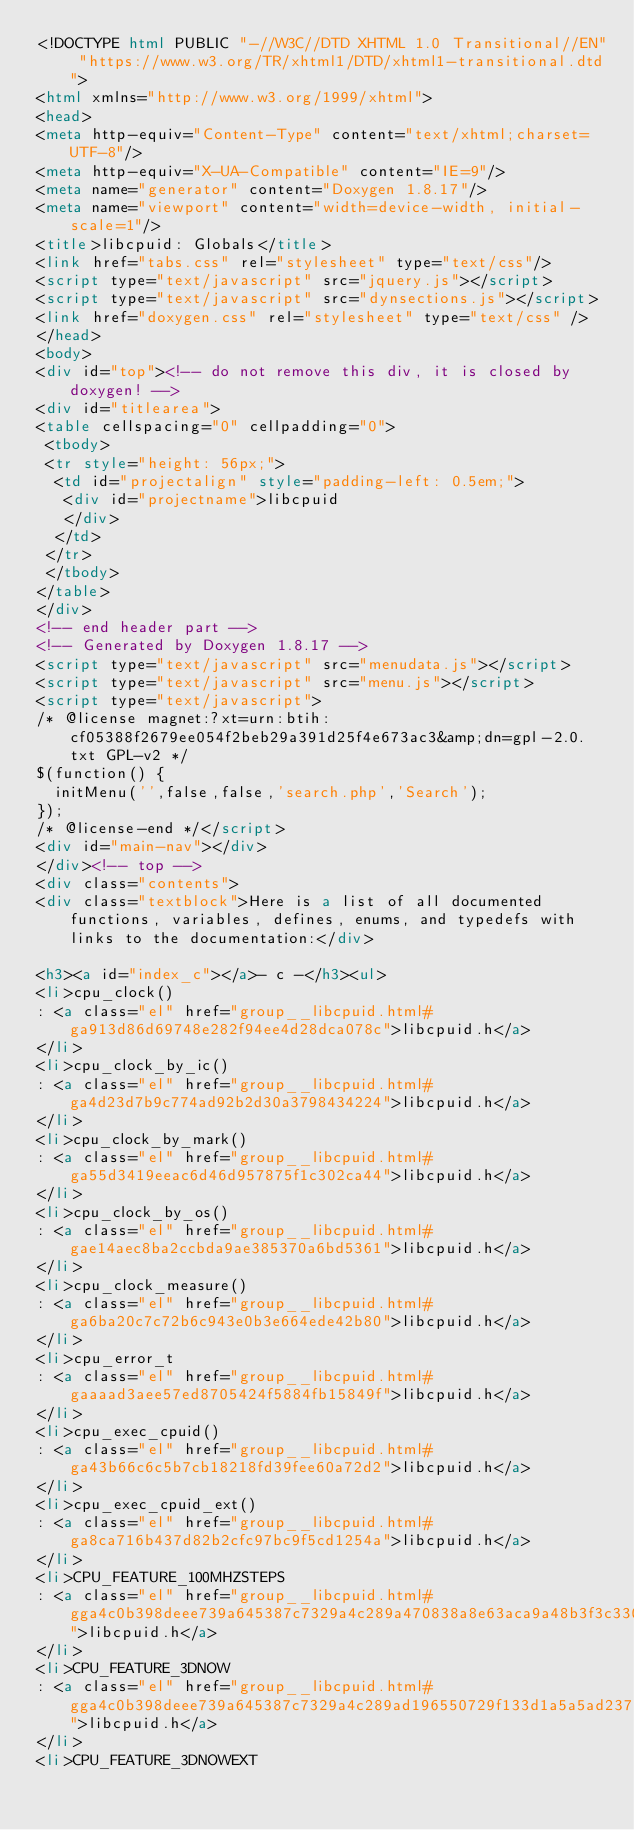Convert code to text. <code><loc_0><loc_0><loc_500><loc_500><_HTML_><!DOCTYPE html PUBLIC "-//W3C//DTD XHTML 1.0 Transitional//EN" "https://www.w3.org/TR/xhtml1/DTD/xhtml1-transitional.dtd">
<html xmlns="http://www.w3.org/1999/xhtml">
<head>
<meta http-equiv="Content-Type" content="text/xhtml;charset=UTF-8"/>
<meta http-equiv="X-UA-Compatible" content="IE=9"/>
<meta name="generator" content="Doxygen 1.8.17"/>
<meta name="viewport" content="width=device-width, initial-scale=1"/>
<title>libcpuid: Globals</title>
<link href="tabs.css" rel="stylesheet" type="text/css"/>
<script type="text/javascript" src="jquery.js"></script>
<script type="text/javascript" src="dynsections.js"></script>
<link href="doxygen.css" rel="stylesheet" type="text/css" />
</head>
<body>
<div id="top"><!-- do not remove this div, it is closed by doxygen! -->
<div id="titlearea">
<table cellspacing="0" cellpadding="0">
 <tbody>
 <tr style="height: 56px;">
  <td id="projectalign" style="padding-left: 0.5em;">
   <div id="projectname">libcpuid
   </div>
  </td>
 </tr>
 </tbody>
</table>
</div>
<!-- end header part -->
<!-- Generated by Doxygen 1.8.17 -->
<script type="text/javascript" src="menudata.js"></script>
<script type="text/javascript" src="menu.js"></script>
<script type="text/javascript">
/* @license magnet:?xt=urn:btih:cf05388f2679ee054f2beb29a391d25f4e673ac3&amp;dn=gpl-2.0.txt GPL-v2 */
$(function() {
  initMenu('',false,false,'search.php','Search');
});
/* @license-end */</script>
<div id="main-nav"></div>
</div><!-- top -->
<div class="contents">
<div class="textblock">Here is a list of all documented functions, variables, defines, enums, and typedefs with links to the documentation:</div>

<h3><a id="index_c"></a>- c -</h3><ul>
<li>cpu_clock()
: <a class="el" href="group__libcpuid.html#ga913d86d69748e282f94ee4d28dca078c">libcpuid.h</a>
</li>
<li>cpu_clock_by_ic()
: <a class="el" href="group__libcpuid.html#ga4d23d7b9c774ad92b2d30a3798434224">libcpuid.h</a>
</li>
<li>cpu_clock_by_mark()
: <a class="el" href="group__libcpuid.html#ga55d3419eeac6d46d957875f1c302ca44">libcpuid.h</a>
</li>
<li>cpu_clock_by_os()
: <a class="el" href="group__libcpuid.html#gae14aec8ba2ccbda9ae385370a6bd5361">libcpuid.h</a>
</li>
<li>cpu_clock_measure()
: <a class="el" href="group__libcpuid.html#ga6ba20c7c72b6c943e0b3e664ede42b80">libcpuid.h</a>
</li>
<li>cpu_error_t
: <a class="el" href="group__libcpuid.html#gaaaad3aee57ed8705424f5884fb15849f">libcpuid.h</a>
</li>
<li>cpu_exec_cpuid()
: <a class="el" href="group__libcpuid.html#ga43b66c6c5b7cb18218fd39fee60a72d2">libcpuid.h</a>
</li>
<li>cpu_exec_cpuid_ext()
: <a class="el" href="group__libcpuid.html#ga8ca716b437d82b2cfc97bc9f5cd1254a">libcpuid.h</a>
</li>
<li>CPU_FEATURE_100MHZSTEPS
: <a class="el" href="group__libcpuid.html#gga4c0b398deee739a645387c7329a4c289a470838a8e63aca9a48b3f3c33030cc54">libcpuid.h</a>
</li>
<li>CPU_FEATURE_3DNOW
: <a class="el" href="group__libcpuid.html#gga4c0b398deee739a645387c7329a4c289ad196550729f133d1a5a5ad2372a1d36f">libcpuid.h</a>
</li>
<li>CPU_FEATURE_3DNOWEXT</code> 